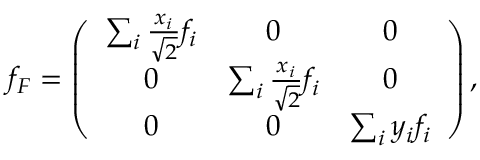<formula> <loc_0><loc_0><loc_500><loc_500>f _ { F } = \left ( \begin{array} { c c c } { { \sum _ { i } \frac { x _ { i } } { \sqrt { 2 } } f _ { i } } } & { 0 } & { 0 } \\ { 0 } & { { \sum _ { i } \frac { x _ { i } } { \sqrt { 2 } } f _ { i } } } & { 0 } \\ { 0 } & { 0 } & { { \sum _ { i } y _ { i } f _ { i } } } \end{array} \right ) ,</formula> 